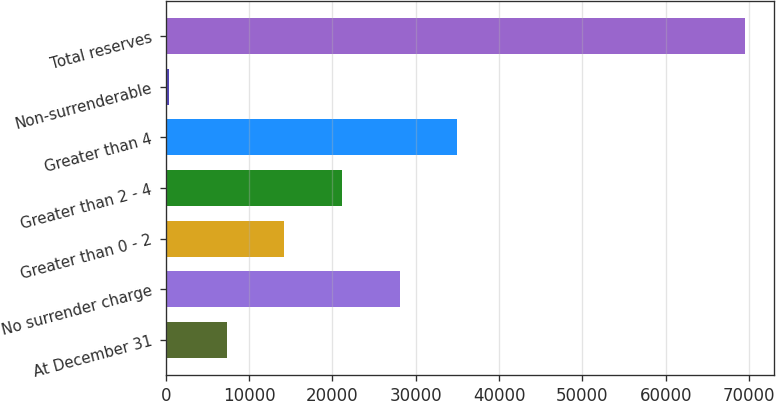Convert chart. <chart><loc_0><loc_0><loc_500><loc_500><bar_chart><fcel>At December 31<fcel>No surrender charge<fcel>Greater than 0 - 2<fcel>Greater than 2 - 4<fcel>Greater than 4<fcel>Non-surrenderable<fcel>Total reserves<nl><fcel>7337.8<fcel>28064.2<fcel>14246.6<fcel>21155.4<fcel>34973<fcel>429<fcel>69517<nl></chart> 